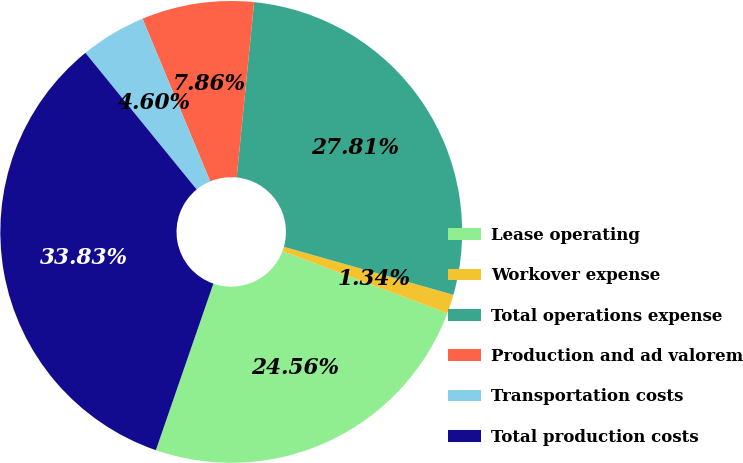Convert chart. <chart><loc_0><loc_0><loc_500><loc_500><pie_chart><fcel>Lease operating<fcel>Workover expense<fcel>Total operations expense<fcel>Production and ad valorem<fcel>Transportation costs<fcel>Total production costs<nl><fcel>24.56%<fcel>1.34%<fcel>27.81%<fcel>7.86%<fcel>4.6%<fcel>33.83%<nl></chart> 